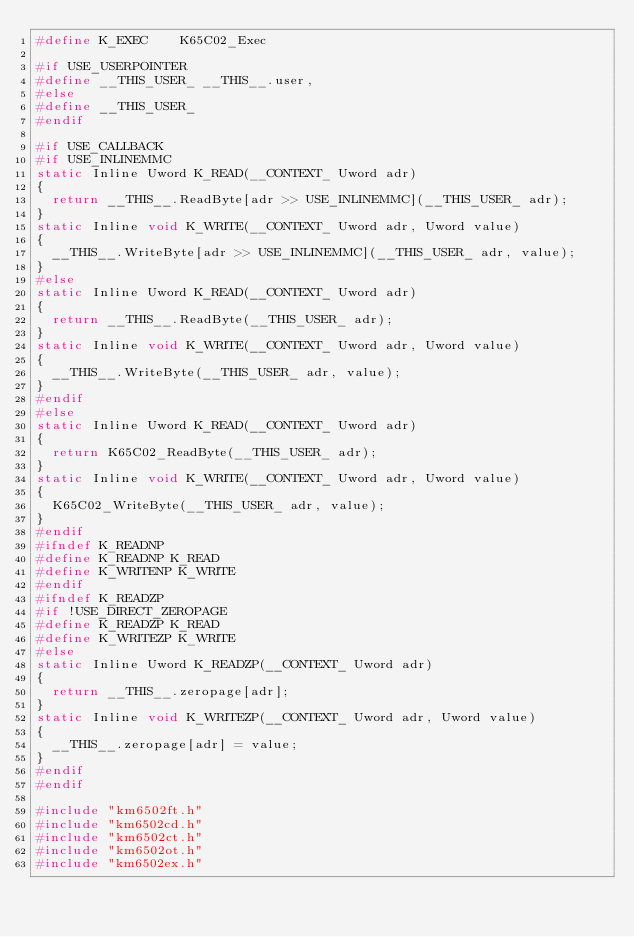Convert code to text. <code><loc_0><loc_0><loc_500><loc_500><_C_>#define K_EXEC		K65C02_Exec

#if USE_USERPOINTER
#define __THIS_USER_ __THIS__.user,
#else
#define __THIS_USER_
#endif

#if USE_CALLBACK
#if USE_INLINEMMC
static Inline Uword K_READ(__CONTEXT_ Uword adr)
{
	return __THIS__.ReadByte[adr >> USE_INLINEMMC](__THIS_USER_ adr);
}
static Inline void K_WRITE(__CONTEXT_ Uword adr, Uword value)
{
	__THIS__.WriteByte[adr >> USE_INLINEMMC](__THIS_USER_ adr, value);
}
#else
static Inline Uword K_READ(__CONTEXT_ Uword adr)
{
	return __THIS__.ReadByte(__THIS_USER_ adr);
}
static Inline void K_WRITE(__CONTEXT_ Uword adr, Uword value)
{
	__THIS__.WriteByte(__THIS_USER_ adr, value);
}
#endif
#else
static Inline Uword K_READ(__CONTEXT_ Uword adr)
{
	return K65C02_ReadByte(__THIS_USER_ adr);
}
static Inline void K_WRITE(__CONTEXT_ Uword adr, Uword value)
{
	K65C02_WriteByte(__THIS_USER_ adr, value);
}
#endif
#ifndef K_READNP
#define K_READNP K_READ
#define K_WRITENP K_WRITE
#endif
#ifndef K_READZP
#if !USE_DIRECT_ZEROPAGE
#define K_READZP K_READ
#define K_WRITEZP K_WRITE
#else
static Inline Uword K_READZP(__CONTEXT_ Uword adr)
{
	return __THIS__.zeropage[adr];
}
static Inline void K_WRITEZP(__CONTEXT_ Uword adr, Uword value)
{
	__THIS__.zeropage[adr] = value;
}
#endif
#endif

#include "km6502ft.h"
#include "km6502cd.h"
#include "km6502ct.h"
#include "km6502ot.h"
#include "km6502ex.h"
</code> 